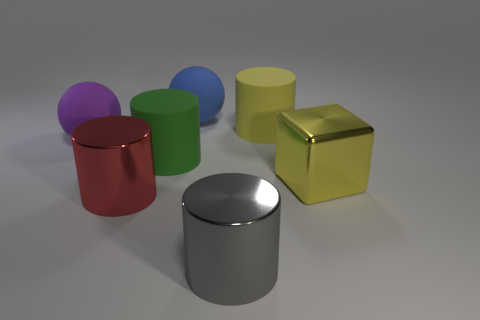Subtract all large yellow cylinders. How many cylinders are left? 3 Add 1 tiny spheres. How many objects exist? 8 Subtract 1 balls. How many balls are left? 1 Subtract all yellow cylinders. How many cylinders are left? 3 Subtract all blocks. How many objects are left? 6 Subtract all yellow cubes. How many yellow cylinders are left? 1 Subtract all purple cylinders. Subtract all brown balls. How many cylinders are left? 4 Add 7 large purple matte things. How many large purple matte things are left? 8 Add 3 purple balls. How many purple balls exist? 4 Subtract 0 brown cylinders. How many objects are left? 7 